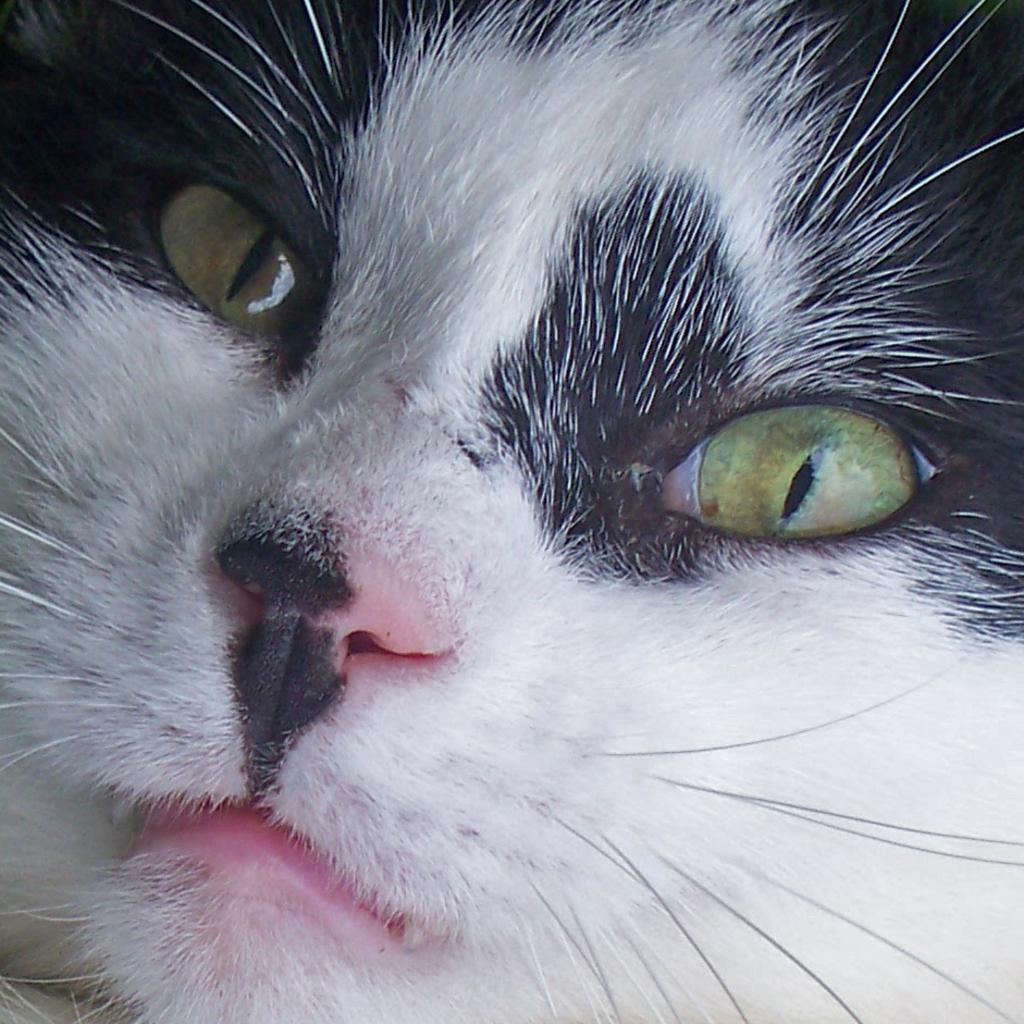How would you summarize this image in a sentence or two? In the picture I can see the cat. 